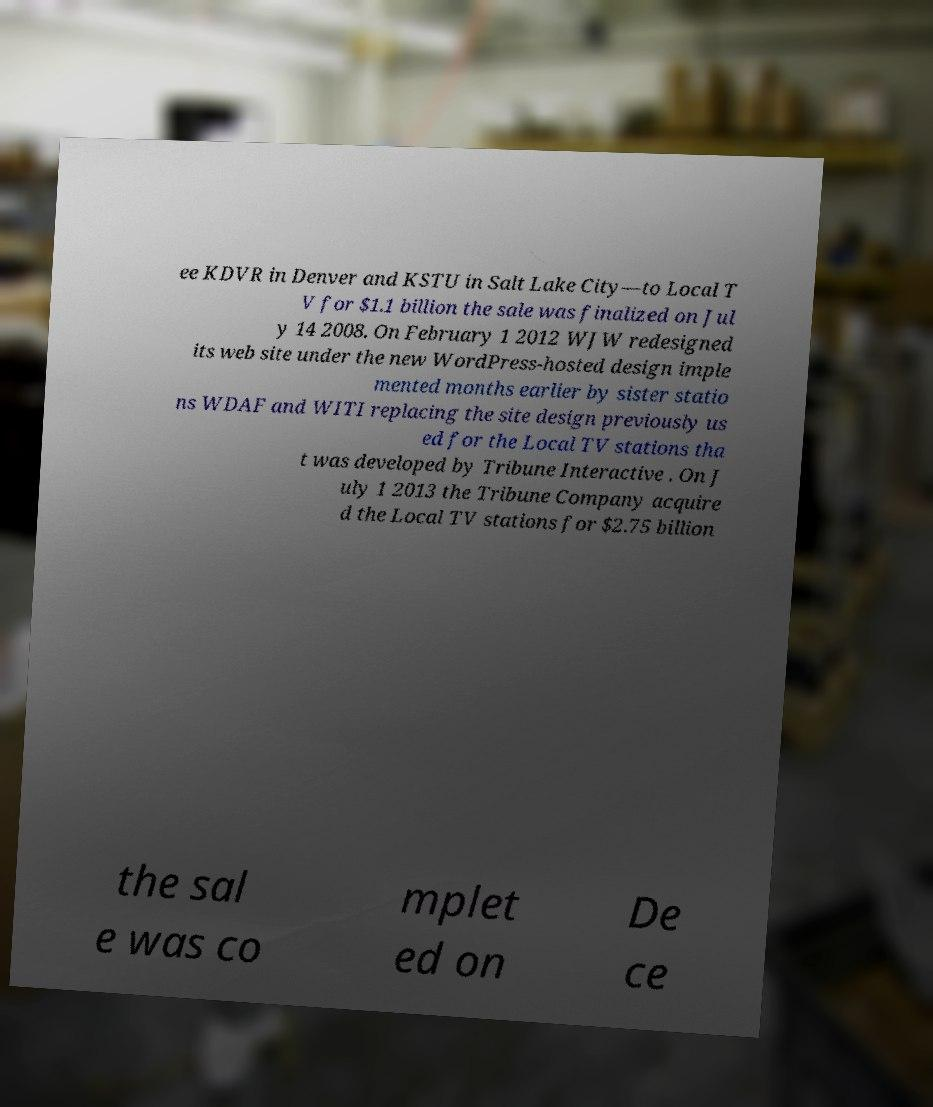Could you extract and type out the text from this image? ee KDVR in Denver and KSTU in Salt Lake City—to Local T V for $1.1 billion the sale was finalized on Jul y 14 2008. On February 1 2012 WJW redesigned its web site under the new WordPress-hosted design imple mented months earlier by sister statio ns WDAF and WITI replacing the site design previously us ed for the Local TV stations tha t was developed by Tribune Interactive . On J uly 1 2013 the Tribune Company acquire d the Local TV stations for $2.75 billion the sal e was co mplet ed on De ce 